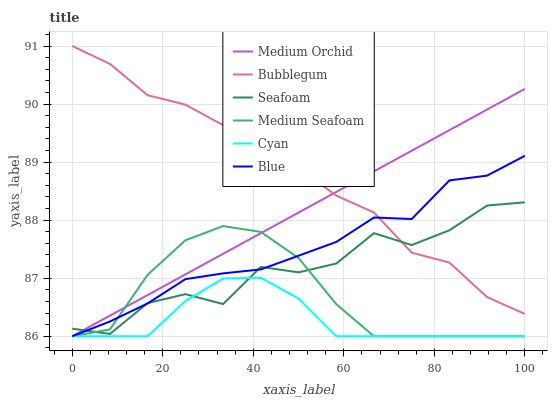Does Cyan have the minimum area under the curve?
Answer yes or no. Yes. Does Bubblegum have the maximum area under the curve?
Answer yes or no. Yes. Does Medium Orchid have the minimum area under the curve?
Answer yes or no. No. Does Medium Orchid have the maximum area under the curve?
Answer yes or no. No. Is Medium Orchid the smoothest?
Answer yes or no. Yes. Is Seafoam the roughest?
Answer yes or no. Yes. Is Seafoam the smoothest?
Answer yes or no. No. Is Medium Orchid the roughest?
Answer yes or no. No. Does Seafoam have the lowest value?
Answer yes or no. No. Does Medium Orchid have the highest value?
Answer yes or no. No. Is Medium Seafoam less than Bubblegum?
Answer yes or no. Yes. Is Bubblegum greater than Medium Seafoam?
Answer yes or no. Yes. Does Medium Seafoam intersect Bubblegum?
Answer yes or no. No. 